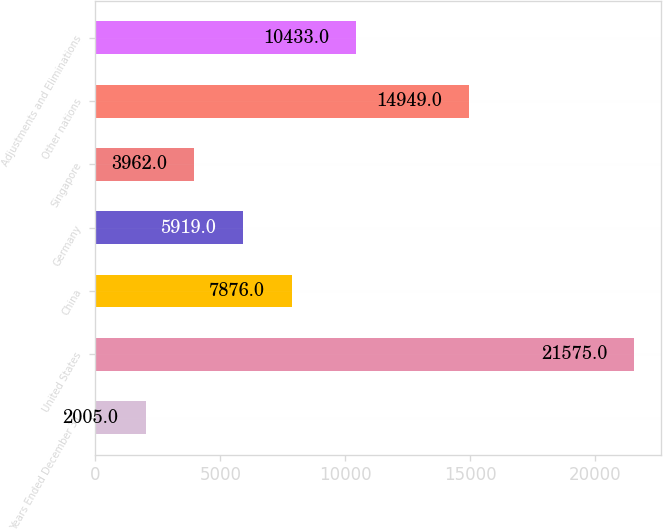<chart> <loc_0><loc_0><loc_500><loc_500><bar_chart><fcel>Years Ended December 31<fcel>United States<fcel>China<fcel>Germany<fcel>Singapore<fcel>Other nations<fcel>Adjustments and Eliminations<nl><fcel>2005<fcel>21575<fcel>7876<fcel>5919<fcel>3962<fcel>14949<fcel>10433<nl></chart> 